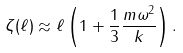<formula> <loc_0><loc_0><loc_500><loc_500>\zeta ( \ell ) \approx \ell \left ( 1 + \frac { 1 } { 3 } \frac { m \omega ^ { 2 } } { k } \right ) .</formula> 